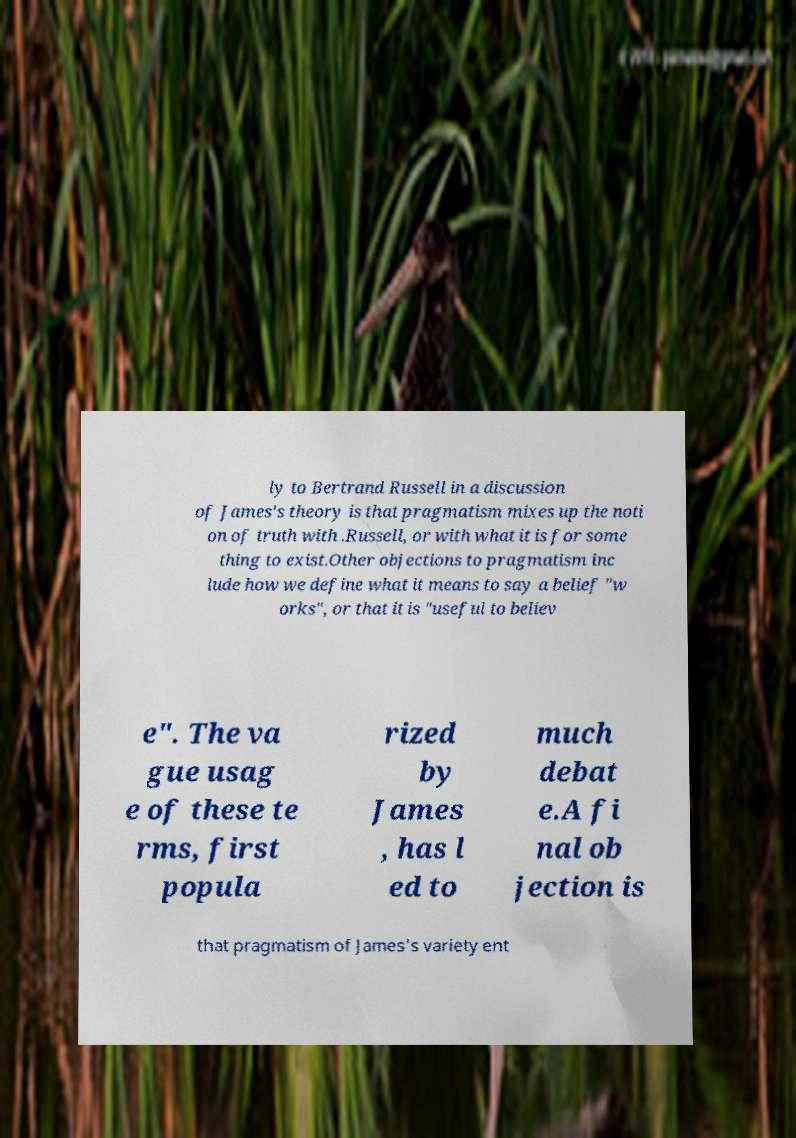Can you accurately transcribe the text from the provided image for me? ly to Bertrand Russell in a discussion of James's theory is that pragmatism mixes up the noti on of truth with .Russell, or with what it is for some thing to exist.Other objections to pragmatism inc lude how we define what it means to say a belief "w orks", or that it is "useful to believ e". The va gue usag e of these te rms, first popula rized by James , has l ed to much debat e.A fi nal ob jection is that pragmatism of James's variety ent 